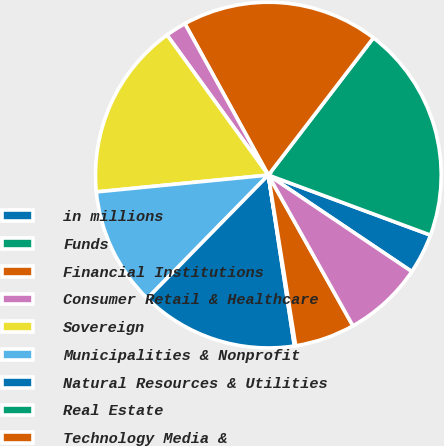<chart> <loc_0><loc_0><loc_500><loc_500><pie_chart><fcel>in millions<fcel>Funds<fcel>Financial Institutions<fcel>Consumer Retail & Healthcare<fcel>Sovereign<fcel>Municipalities & Nonprofit<fcel>Natural Resources & Utilities<fcel>Real Estate<fcel>Technology Media &<fcel>Diversified Industrials<nl><fcel>3.78%<fcel>20.25%<fcel>18.42%<fcel>1.95%<fcel>16.59%<fcel>11.1%<fcel>14.76%<fcel>0.12%<fcel>5.61%<fcel>7.44%<nl></chart> 